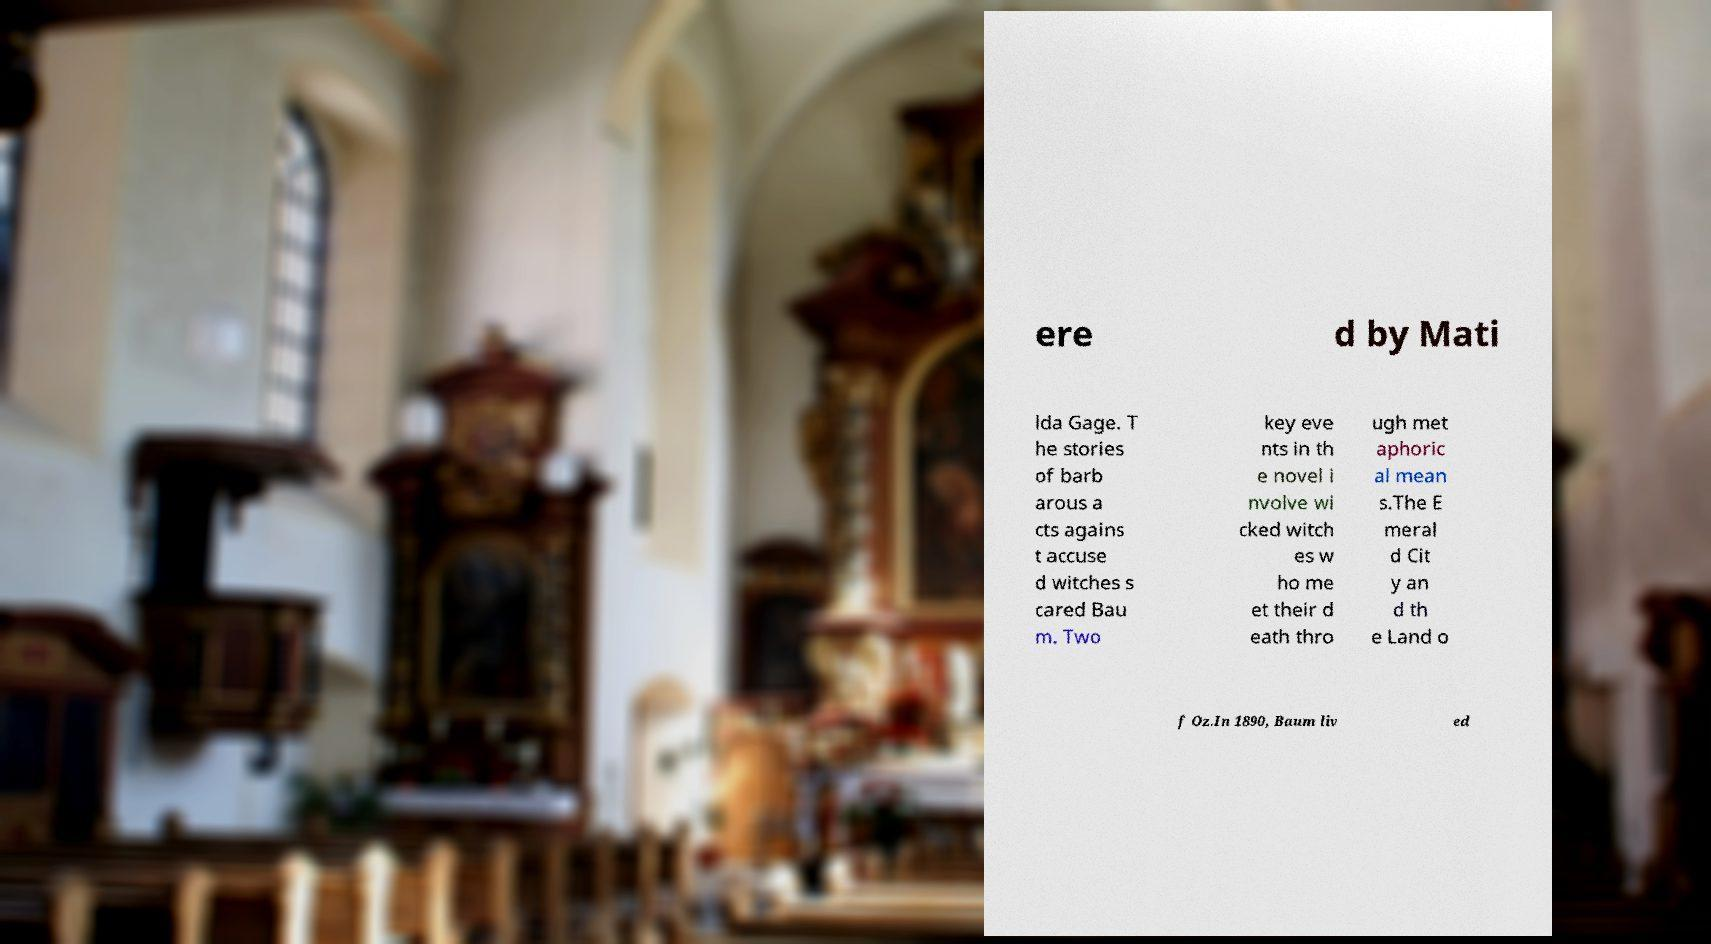Please identify and transcribe the text found in this image. ere d by Mati lda Gage. T he stories of barb arous a cts agains t accuse d witches s cared Bau m. Two key eve nts in th e novel i nvolve wi cked witch es w ho me et their d eath thro ugh met aphoric al mean s.The E meral d Cit y an d th e Land o f Oz.In 1890, Baum liv ed 